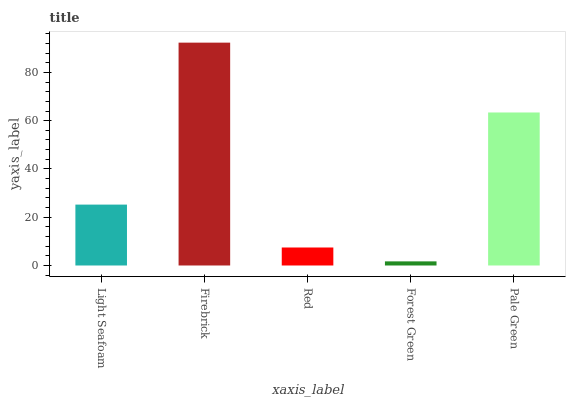Is Forest Green the minimum?
Answer yes or no. Yes. Is Firebrick the maximum?
Answer yes or no. Yes. Is Red the minimum?
Answer yes or no. No. Is Red the maximum?
Answer yes or no. No. Is Firebrick greater than Red?
Answer yes or no. Yes. Is Red less than Firebrick?
Answer yes or no. Yes. Is Red greater than Firebrick?
Answer yes or no. No. Is Firebrick less than Red?
Answer yes or no. No. Is Light Seafoam the high median?
Answer yes or no. Yes. Is Light Seafoam the low median?
Answer yes or no. Yes. Is Forest Green the high median?
Answer yes or no. No. Is Firebrick the low median?
Answer yes or no. No. 